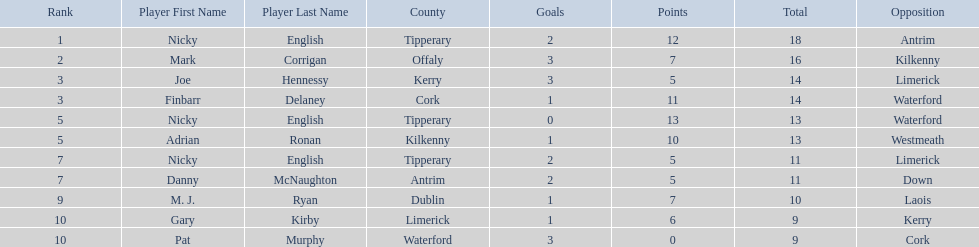Who are all the players? Nicky English, Mark Corrigan, Joe Hennessy, Finbarr Delaney, Nicky English, Adrian Ronan, Nicky English, Danny McNaughton, M. J. Ryan, Gary Kirby, Pat Murphy. How many points did they receive? 18, 16, 14, 14, 13, 13, 11, 11, 10, 9, 9. And which player received 10 points? M. J. Ryan. 